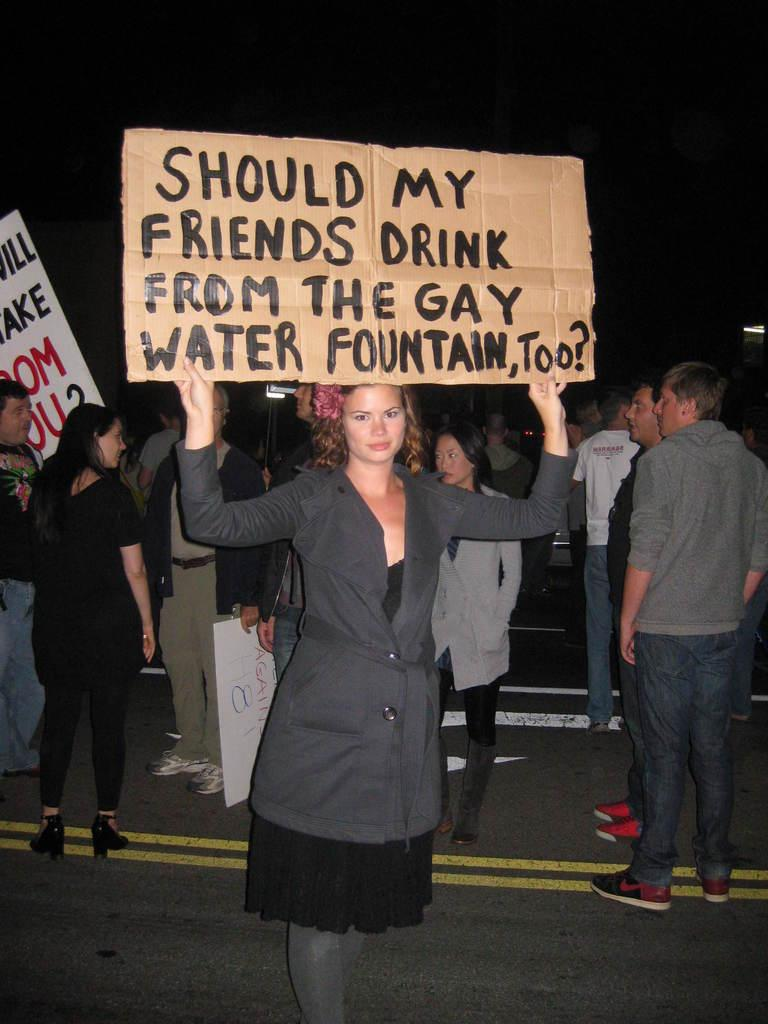What is the main feature of the image? There is a road in the image. What are the people doing on the road? Some of the people are standing on the road, and some of them are holding boards. What can be seen on the boards? There is writing on the boards. What type of competition is taking place on the road in the image? There is no competition present in the image; it only shows people standing on the road with boards. What kind of punishment is being handed out to the people on the road in the image? There is no punishment being handed out in the image; the people are simply standing on the road with boards. 